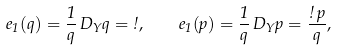<formula> <loc_0><loc_0><loc_500><loc_500>e _ { 1 } ( q ) = \frac { 1 } { q } \, D _ { Y } q = \omega , \quad e _ { 1 } ( p ) = \frac { 1 } { q } \, D _ { Y } p = \frac { \omega \, p } { q } ,</formula> 